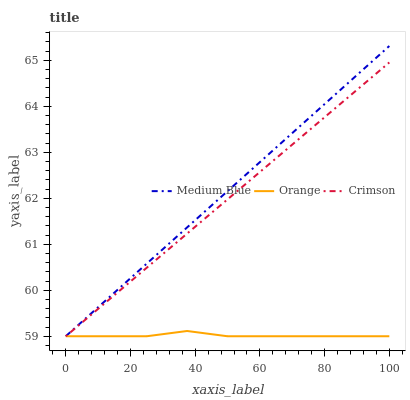Does Orange have the minimum area under the curve?
Answer yes or no. Yes. Does Medium Blue have the maximum area under the curve?
Answer yes or no. Yes. Does Crimson have the minimum area under the curve?
Answer yes or no. No. Does Crimson have the maximum area under the curve?
Answer yes or no. No. Is Crimson the smoothest?
Answer yes or no. Yes. Is Orange the roughest?
Answer yes or no. Yes. Is Medium Blue the smoothest?
Answer yes or no. No. Is Medium Blue the roughest?
Answer yes or no. No. Does Orange have the lowest value?
Answer yes or no. Yes. Does Medium Blue have the highest value?
Answer yes or no. Yes. Does Crimson have the highest value?
Answer yes or no. No. Does Medium Blue intersect Orange?
Answer yes or no. Yes. Is Medium Blue less than Orange?
Answer yes or no. No. Is Medium Blue greater than Orange?
Answer yes or no. No. 